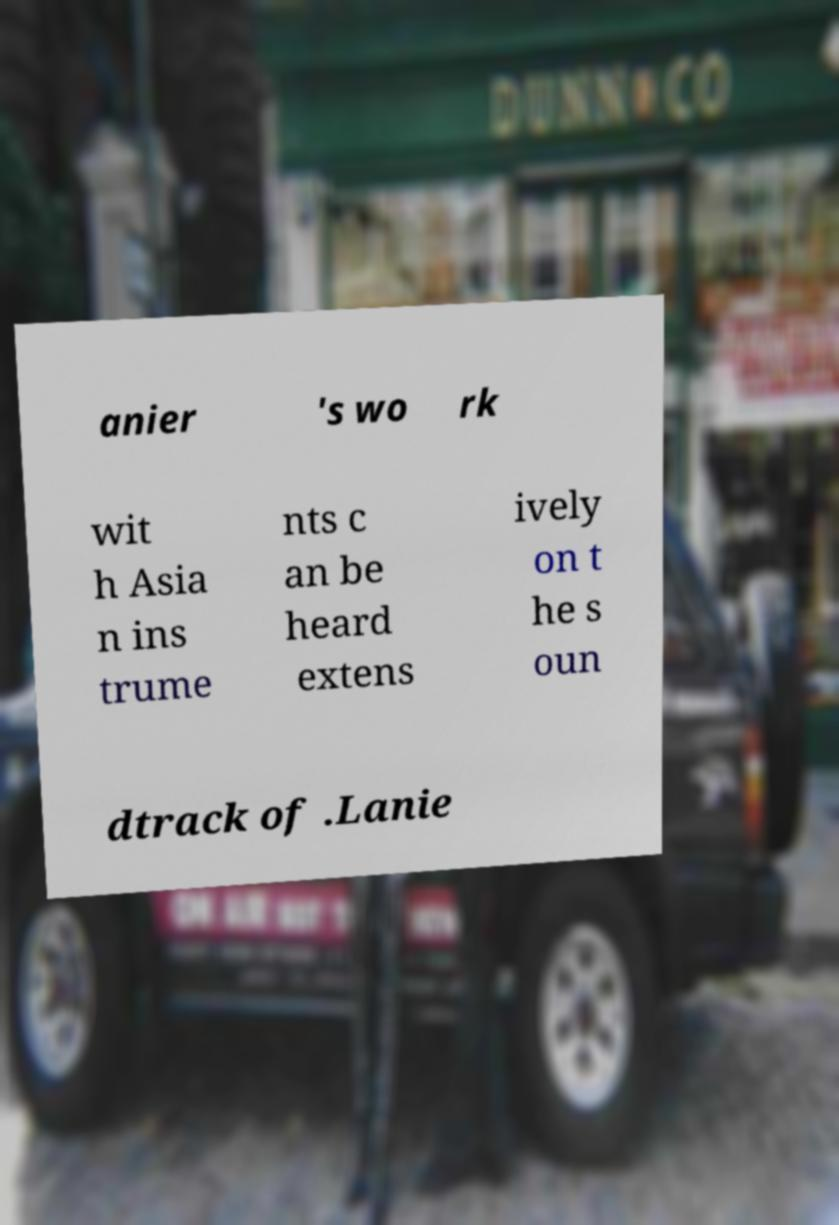Please identify and transcribe the text found in this image. anier 's wo rk wit h Asia n ins trume nts c an be heard extens ively on t he s oun dtrack of .Lanie 